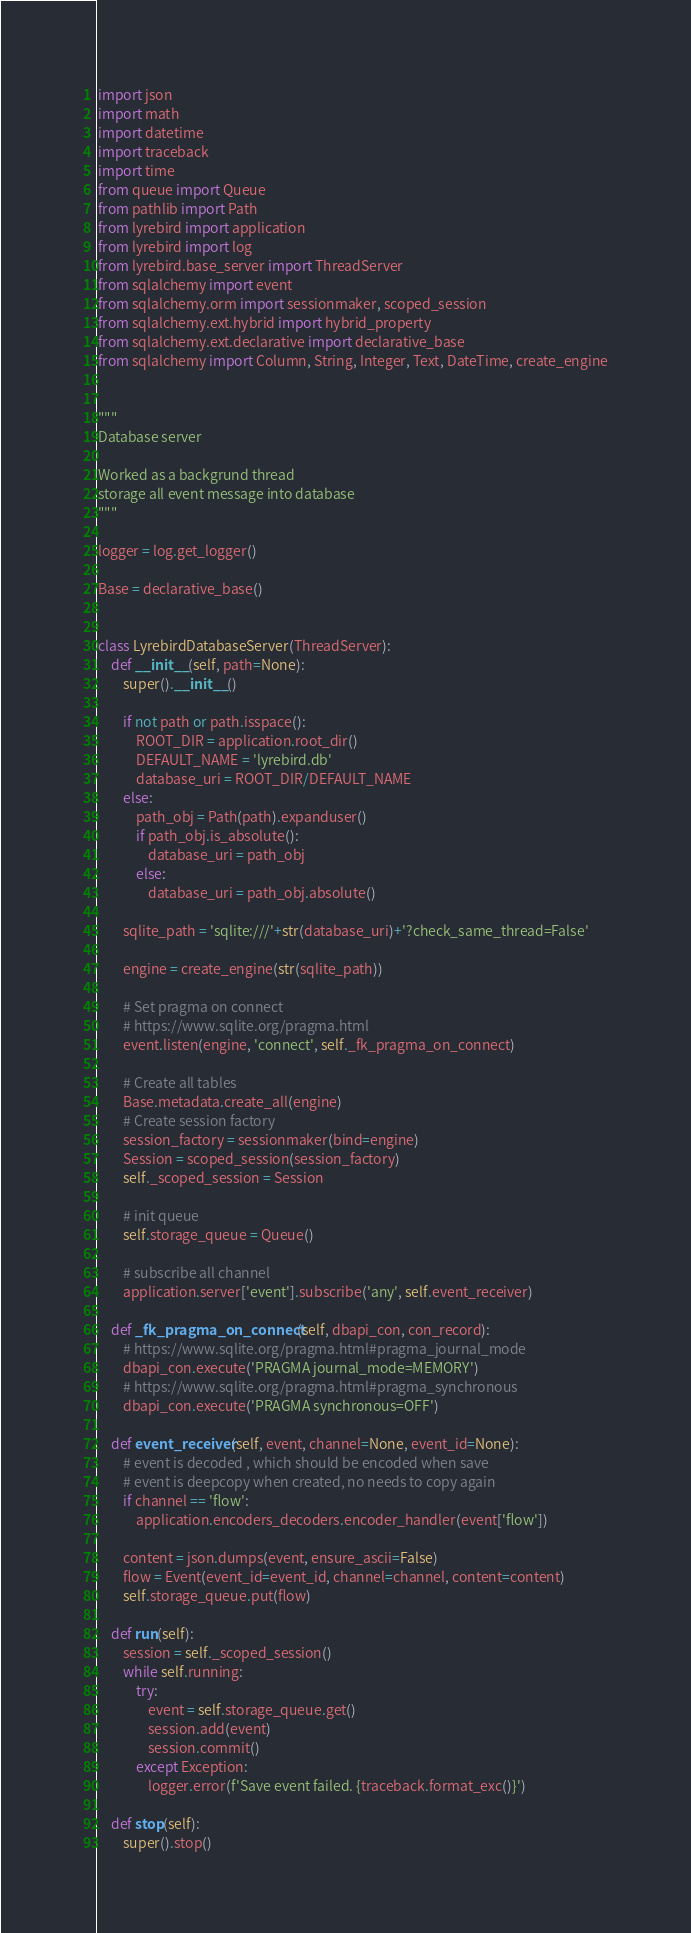<code> <loc_0><loc_0><loc_500><loc_500><_Python_>import json
import math
import datetime
import traceback
import time
from queue import Queue
from pathlib import Path
from lyrebird import application
from lyrebird import log
from lyrebird.base_server import ThreadServer
from sqlalchemy import event
from sqlalchemy.orm import sessionmaker, scoped_session
from sqlalchemy.ext.hybrid import hybrid_property
from sqlalchemy.ext.declarative import declarative_base
from sqlalchemy import Column, String, Integer, Text, DateTime, create_engine


"""
Database server

Worked as a backgrund thread
storage all event message into database
"""

logger = log.get_logger()

Base = declarative_base()


class LyrebirdDatabaseServer(ThreadServer):
    def __init__(self, path=None):
        super().__init__()

        if not path or path.isspace():
            ROOT_DIR = application.root_dir()
            DEFAULT_NAME = 'lyrebird.db'
            database_uri = ROOT_DIR/DEFAULT_NAME
        else:
            path_obj = Path(path).expanduser()
            if path_obj.is_absolute():
                database_uri = path_obj
            else:
                database_uri = path_obj.absolute()

        sqlite_path = 'sqlite:///'+str(database_uri)+'?check_same_thread=False'

        engine = create_engine(str(sqlite_path))

        # Set pragma on connect
        # https://www.sqlite.org/pragma.html
        event.listen(engine, 'connect', self._fk_pragma_on_connect)

        # Create all tables
        Base.metadata.create_all(engine)
        # Create session factory
        session_factory = sessionmaker(bind=engine)
        Session = scoped_session(session_factory)
        self._scoped_session = Session

        # init queue
        self.storage_queue = Queue()

        # subscribe all channel
        application.server['event'].subscribe('any', self.event_receiver)

    def _fk_pragma_on_connect(self, dbapi_con, con_record):
        # https://www.sqlite.org/pragma.html#pragma_journal_mode
        dbapi_con.execute('PRAGMA journal_mode=MEMORY')
        # https://www.sqlite.org/pragma.html#pragma_synchronous
        dbapi_con.execute('PRAGMA synchronous=OFF')

    def event_receiver(self, event, channel=None, event_id=None):
        # event is decoded , which should be encoded when save
        # event is deepcopy when created, no needs to copy again
        if channel == 'flow':
            application.encoders_decoders.encoder_handler(event['flow'])

        content = json.dumps(event, ensure_ascii=False)
        flow = Event(event_id=event_id, channel=channel, content=content)
        self.storage_queue.put(flow)

    def run(self):
        session = self._scoped_session()
        while self.running:
            try:
                event = self.storage_queue.get()
                session.add(event)
                session.commit()
            except Exception:
                logger.error(f'Save event failed. {traceback.format_exc()}')

    def stop(self):
        super().stop()
</code> 